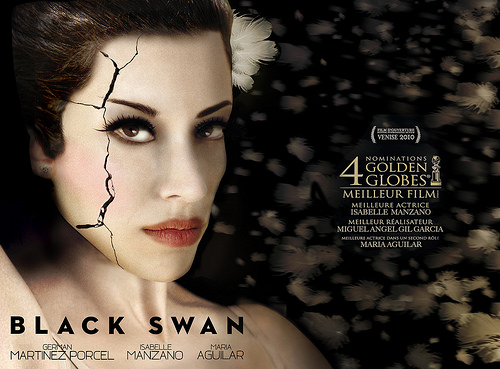<image>
Is the woman under the crack? Yes. The woman is positioned underneath the crack, with the crack above it in the vertical space. 